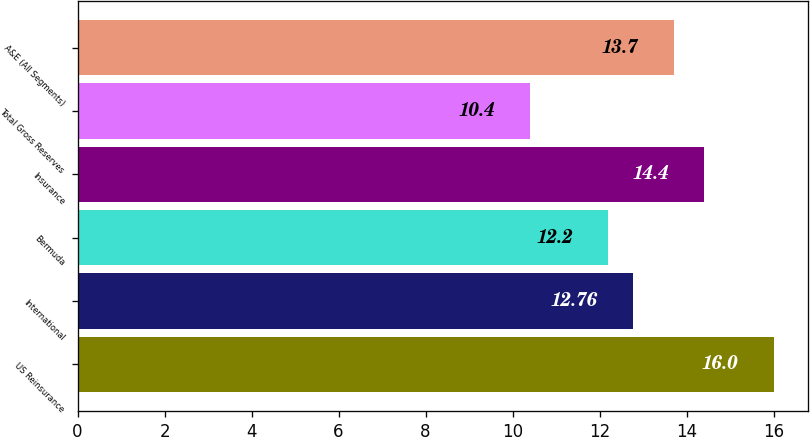Convert chart. <chart><loc_0><loc_0><loc_500><loc_500><bar_chart><fcel>US Reinsurance<fcel>International<fcel>Bermuda<fcel>Insurance<fcel>Total Gross Reserves<fcel>A&E (All Segments)<nl><fcel>16<fcel>12.76<fcel>12.2<fcel>14.4<fcel>10.4<fcel>13.7<nl></chart> 